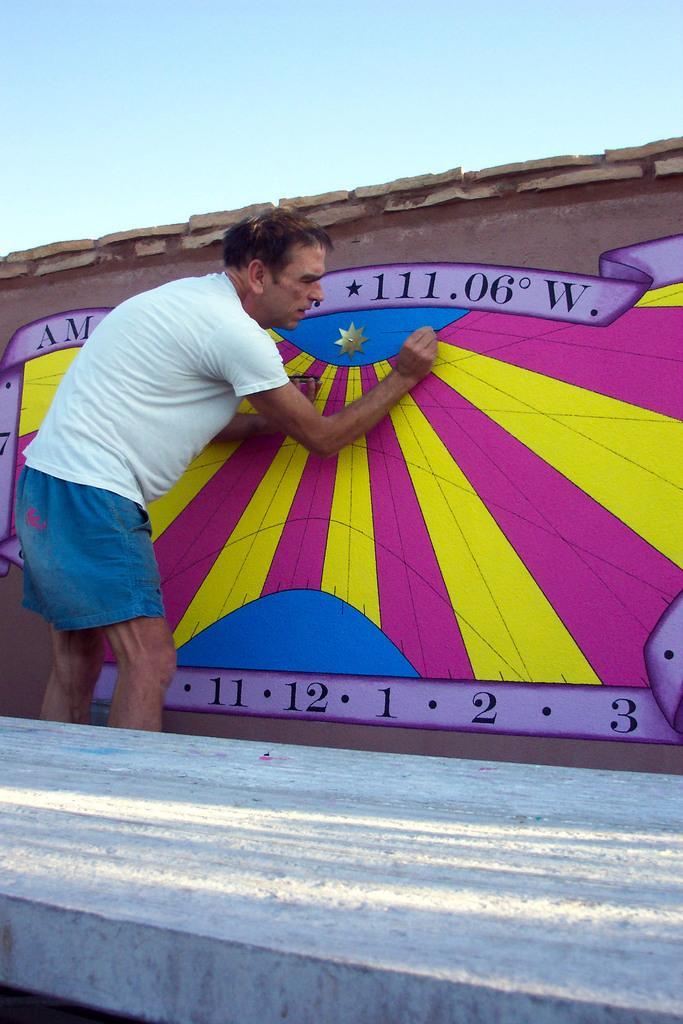In one or two sentences, can you explain what this image depicts? In this image I see a man over here who is wearing white t-shirt and blue shorts and I see the painting on this wall and I see that it is colorful and I see numbers and few alphabets and in the background I see the sky. 